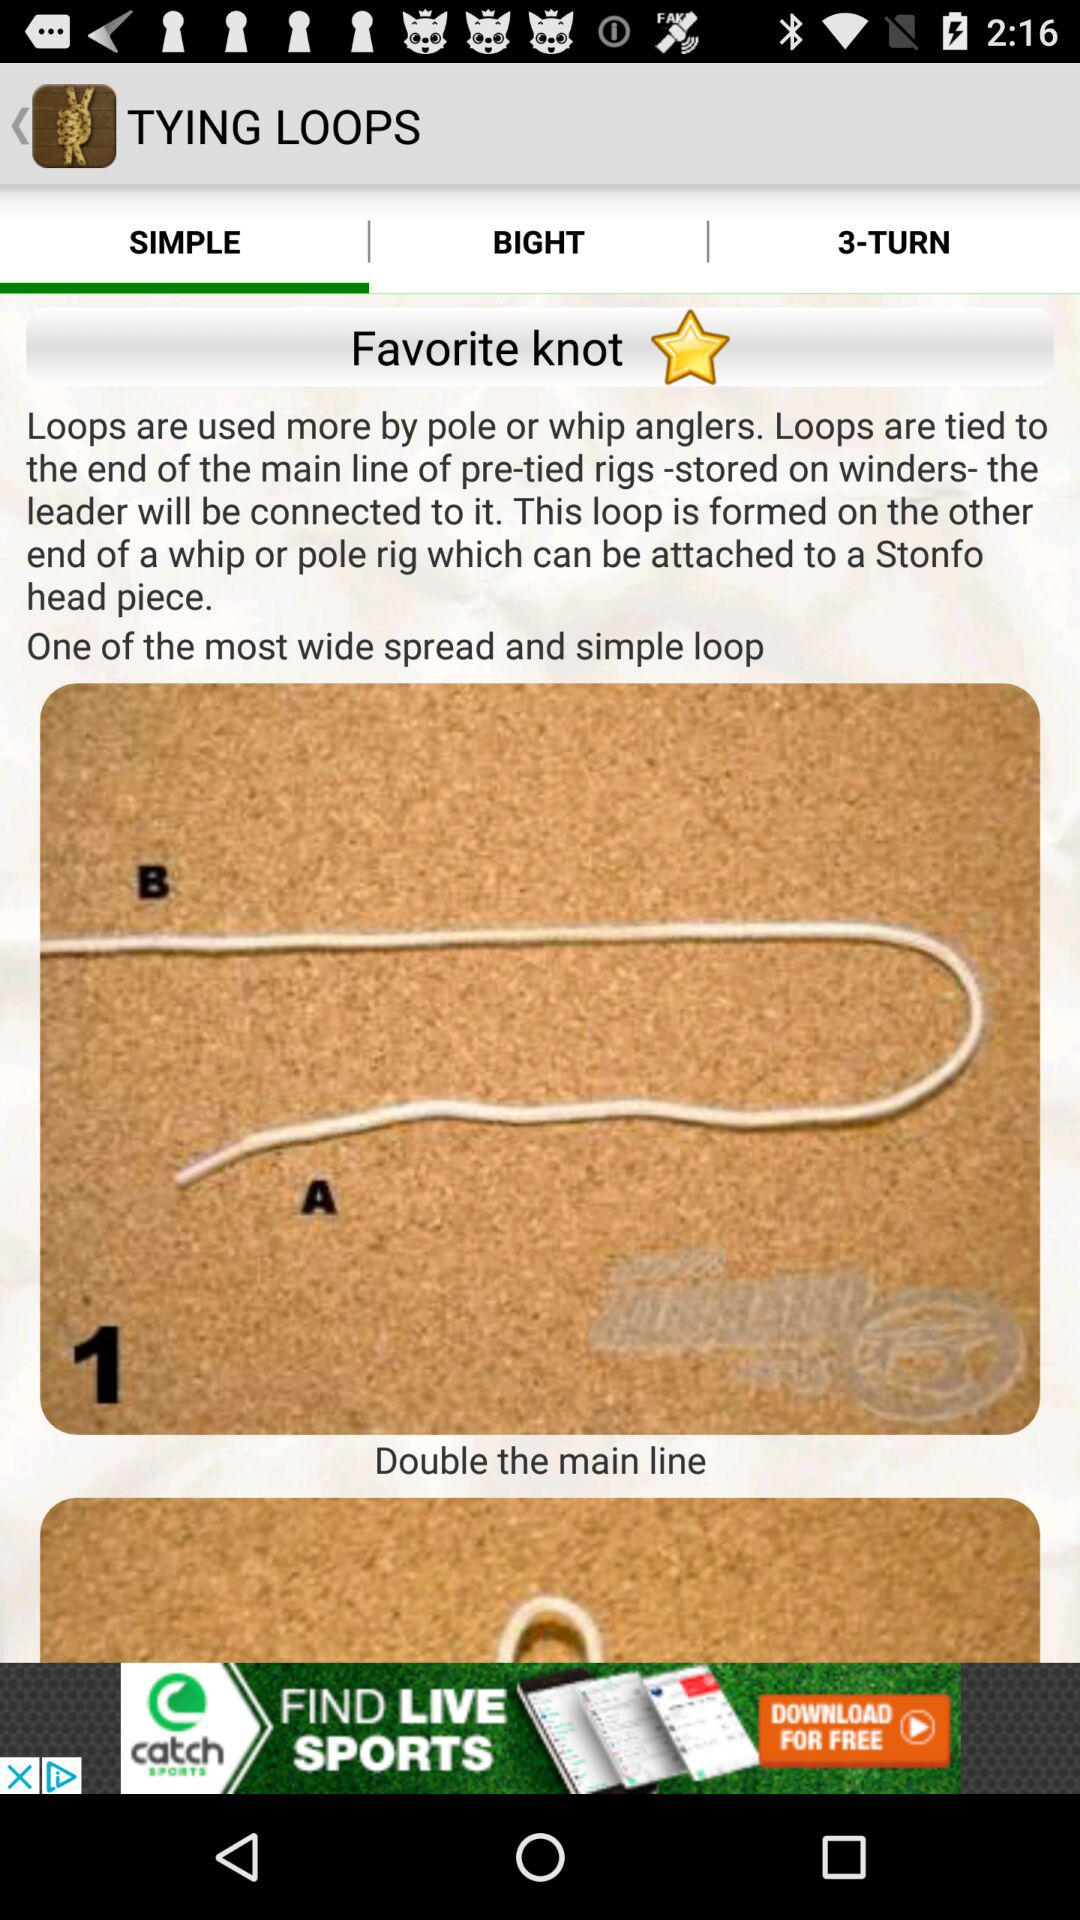How many steps are there in the instructions for the simple loop?
Answer the question using a single word or phrase. 2 